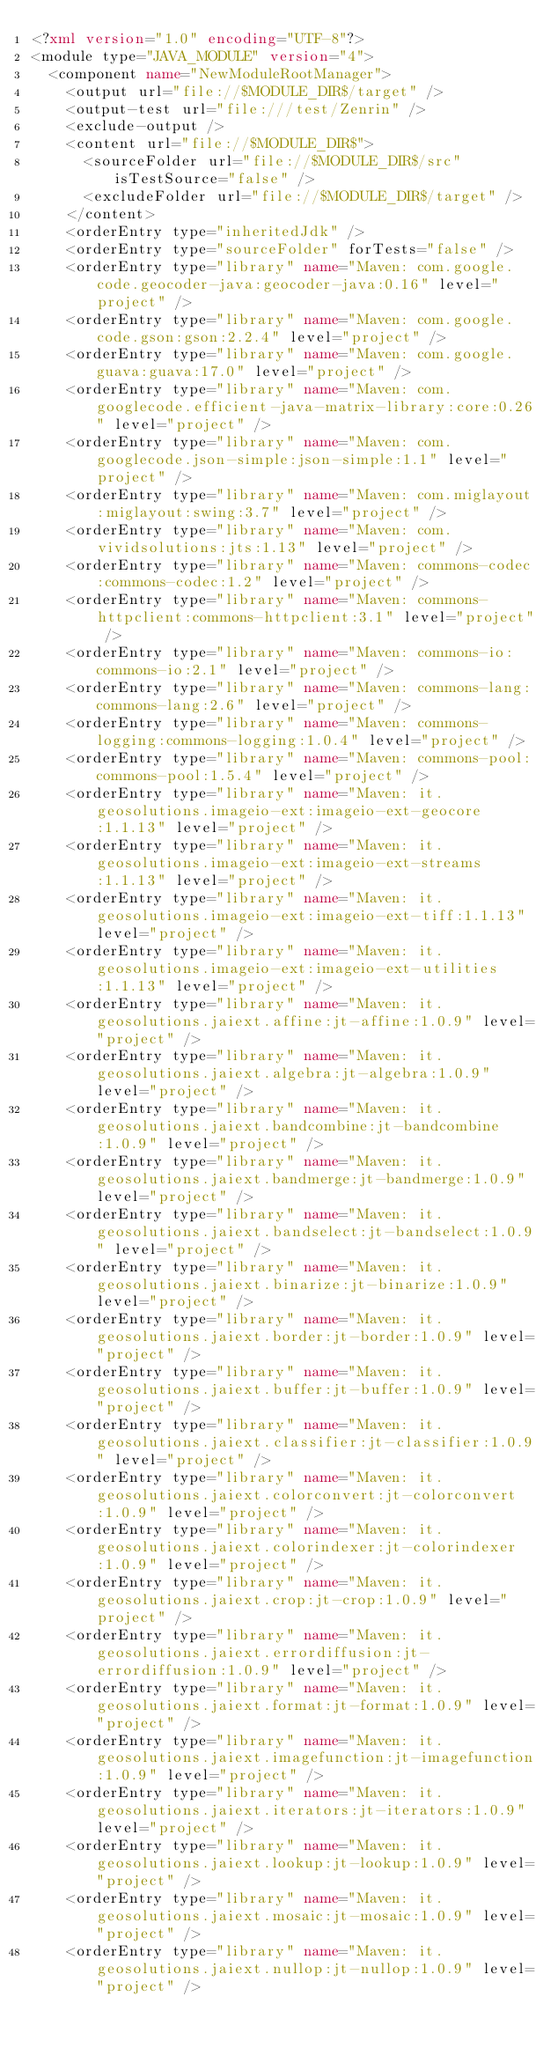<code> <loc_0><loc_0><loc_500><loc_500><_XML_><?xml version="1.0" encoding="UTF-8"?>
<module type="JAVA_MODULE" version="4">
  <component name="NewModuleRootManager">
    <output url="file://$MODULE_DIR$/target" />
    <output-test url="file:///test/Zenrin" />
    <exclude-output />
    <content url="file://$MODULE_DIR$">
      <sourceFolder url="file://$MODULE_DIR$/src" isTestSource="false" />
      <excludeFolder url="file://$MODULE_DIR$/target" />
    </content>
    <orderEntry type="inheritedJdk" />
    <orderEntry type="sourceFolder" forTests="false" />
    <orderEntry type="library" name="Maven: com.google.code.geocoder-java:geocoder-java:0.16" level="project" />
    <orderEntry type="library" name="Maven: com.google.code.gson:gson:2.2.4" level="project" />
    <orderEntry type="library" name="Maven: com.google.guava:guava:17.0" level="project" />
    <orderEntry type="library" name="Maven: com.googlecode.efficient-java-matrix-library:core:0.26" level="project" />
    <orderEntry type="library" name="Maven: com.googlecode.json-simple:json-simple:1.1" level="project" />
    <orderEntry type="library" name="Maven: com.miglayout:miglayout:swing:3.7" level="project" />
    <orderEntry type="library" name="Maven: com.vividsolutions:jts:1.13" level="project" />
    <orderEntry type="library" name="Maven: commons-codec:commons-codec:1.2" level="project" />
    <orderEntry type="library" name="Maven: commons-httpclient:commons-httpclient:3.1" level="project" />
    <orderEntry type="library" name="Maven: commons-io:commons-io:2.1" level="project" />
    <orderEntry type="library" name="Maven: commons-lang:commons-lang:2.6" level="project" />
    <orderEntry type="library" name="Maven: commons-logging:commons-logging:1.0.4" level="project" />
    <orderEntry type="library" name="Maven: commons-pool:commons-pool:1.5.4" level="project" />
    <orderEntry type="library" name="Maven: it.geosolutions.imageio-ext:imageio-ext-geocore:1.1.13" level="project" />
    <orderEntry type="library" name="Maven: it.geosolutions.imageio-ext:imageio-ext-streams:1.1.13" level="project" />
    <orderEntry type="library" name="Maven: it.geosolutions.imageio-ext:imageio-ext-tiff:1.1.13" level="project" />
    <orderEntry type="library" name="Maven: it.geosolutions.imageio-ext:imageio-ext-utilities:1.1.13" level="project" />
    <orderEntry type="library" name="Maven: it.geosolutions.jaiext.affine:jt-affine:1.0.9" level="project" />
    <orderEntry type="library" name="Maven: it.geosolutions.jaiext.algebra:jt-algebra:1.0.9" level="project" />
    <orderEntry type="library" name="Maven: it.geosolutions.jaiext.bandcombine:jt-bandcombine:1.0.9" level="project" />
    <orderEntry type="library" name="Maven: it.geosolutions.jaiext.bandmerge:jt-bandmerge:1.0.9" level="project" />
    <orderEntry type="library" name="Maven: it.geosolutions.jaiext.bandselect:jt-bandselect:1.0.9" level="project" />
    <orderEntry type="library" name="Maven: it.geosolutions.jaiext.binarize:jt-binarize:1.0.9" level="project" />
    <orderEntry type="library" name="Maven: it.geosolutions.jaiext.border:jt-border:1.0.9" level="project" />
    <orderEntry type="library" name="Maven: it.geosolutions.jaiext.buffer:jt-buffer:1.0.9" level="project" />
    <orderEntry type="library" name="Maven: it.geosolutions.jaiext.classifier:jt-classifier:1.0.9" level="project" />
    <orderEntry type="library" name="Maven: it.geosolutions.jaiext.colorconvert:jt-colorconvert:1.0.9" level="project" />
    <orderEntry type="library" name="Maven: it.geosolutions.jaiext.colorindexer:jt-colorindexer:1.0.9" level="project" />
    <orderEntry type="library" name="Maven: it.geosolutions.jaiext.crop:jt-crop:1.0.9" level="project" />
    <orderEntry type="library" name="Maven: it.geosolutions.jaiext.errordiffusion:jt-errordiffusion:1.0.9" level="project" />
    <orderEntry type="library" name="Maven: it.geosolutions.jaiext.format:jt-format:1.0.9" level="project" />
    <orderEntry type="library" name="Maven: it.geosolutions.jaiext.imagefunction:jt-imagefunction:1.0.9" level="project" />
    <orderEntry type="library" name="Maven: it.geosolutions.jaiext.iterators:jt-iterators:1.0.9" level="project" />
    <orderEntry type="library" name="Maven: it.geosolutions.jaiext.lookup:jt-lookup:1.0.9" level="project" />
    <orderEntry type="library" name="Maven: it.geosolutions.jaiext.mosaic:jt-mosaic:1.0.9" level="project" />
    <orderEntry type="library" name="Maven: it.geosolutions.jaiext.nullop:jt-nullop:1.0.9" level="project" /></code> 